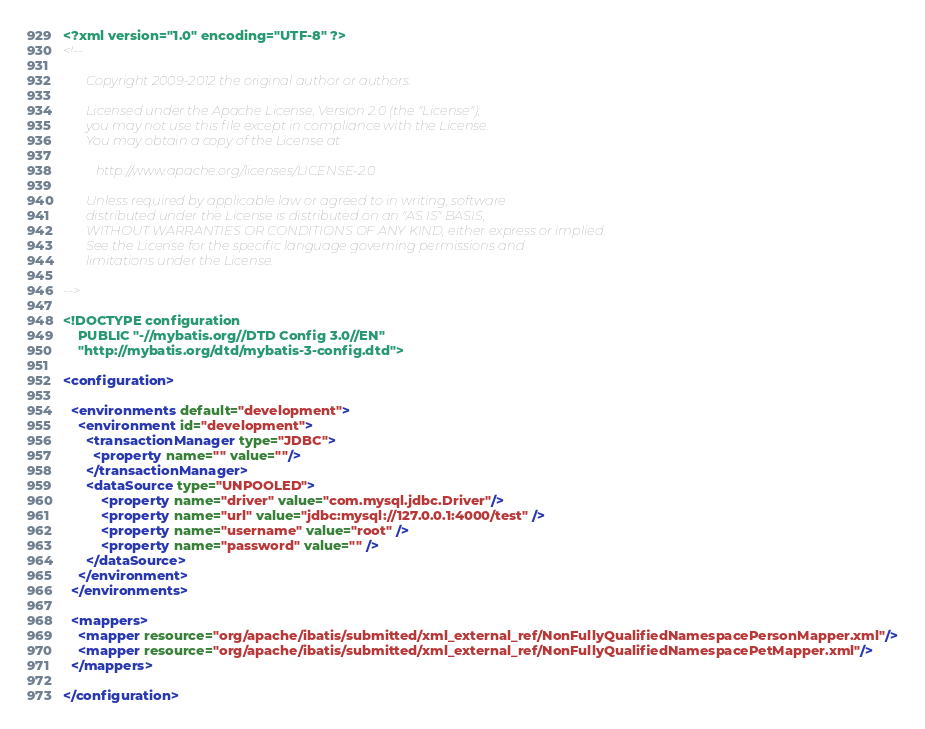Convert code to text. <code><loc_0><loc_0><loc_500><loc_500><_XML_><?xml version="1.0" encoding="UTF-8" ?>
<!--

       Copyright 2009-2012 the original author or authors.

       Licensed under the Apache License, Version 2.0 (the "License");
       you may not use this file except in compliance with the License.
       You may obtain a copy of the License at

          http://www.apache.org/licenses/LICENSE-2.0

       Unless required by applicable law or agreed to in writing, software
       distributed under the License is distributed on an "AS IS" BASIS,
       WITHOUT WARRANTIES OR CONDITIONS OF ANY KIND, either express or implied.
       See the License for the specific language governing permissions and
       limitations under the License.

-->

<!DOCTYPE configuration
    PUBLIC "-//mybatis.org//DTD Config 3.0//EN"
    "http://mybatis.org/dtd/mybatis-3-config.dtd">

<configuration>

  <environments default="development">
    <environment id="development">
      <transactionManager type="JDBC">
        <property name="" value=""/>
      </transactionManager>
      <dataSource type="UNPOOLED">
          <property name="driver" value="com.mysql.jdbc.Driver"/>
          <property name="url" value="jdbc:mysql://127.0.0.1:4000/test" />
          <property name="username" value="root" />
          <property name="password" value="" />
      </dataSource>
    </environment>
  </environments>

  <mappers>
    <mapper resource="org/apache/ibatis/submitted/xml_external_ref/NonFullyQualifiedNamespacePersonMapper.xml"/>
    <mapper resource="org/apache/ibatis/submitted/xml_external_ref/NonFullyQualifiedNamespacePetMapper.xml"/>
  </mappers>

</configuration>
</code> 